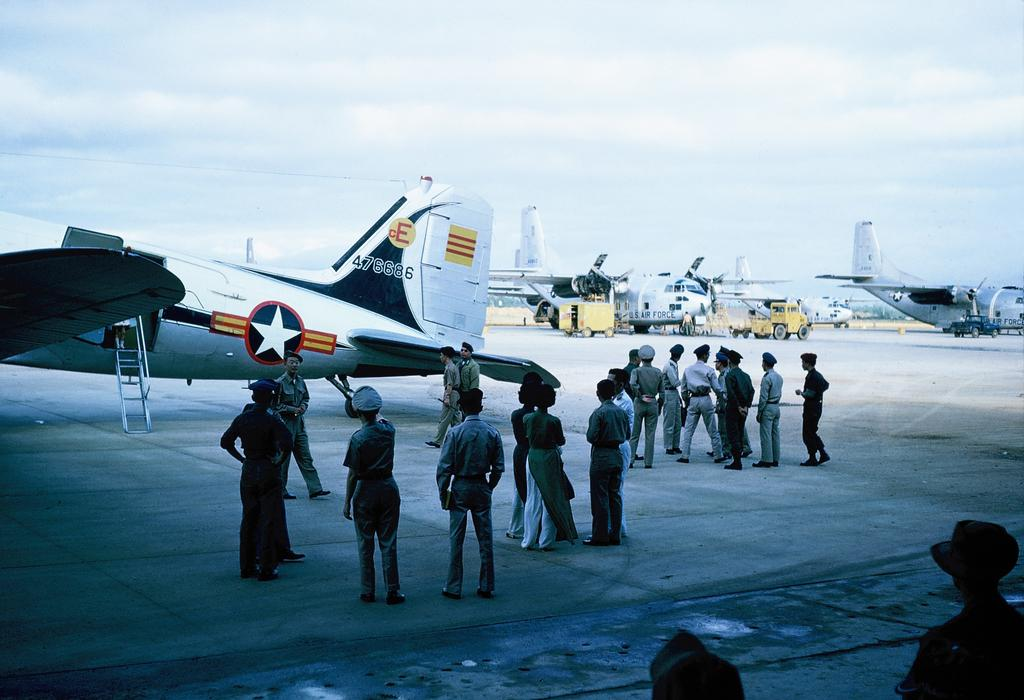What is happening in the image involving people? There is a group of people standing in the image. What can be seen on the runway in the image? There are airplanes on the runway in the image. What types of transportation are visible in the image? There are vehicles in the image. How would you describe the weather based on the sky in the image? The sky is cloudy in the image. How many robins are sitting on the chairs in the image? There are no robins or chairs present in the image. What type of battle is taking place in the image? There is no battle depicted in the image; it features a group of people, airplanes on the runway, vehicles, and a cloudy sky. 